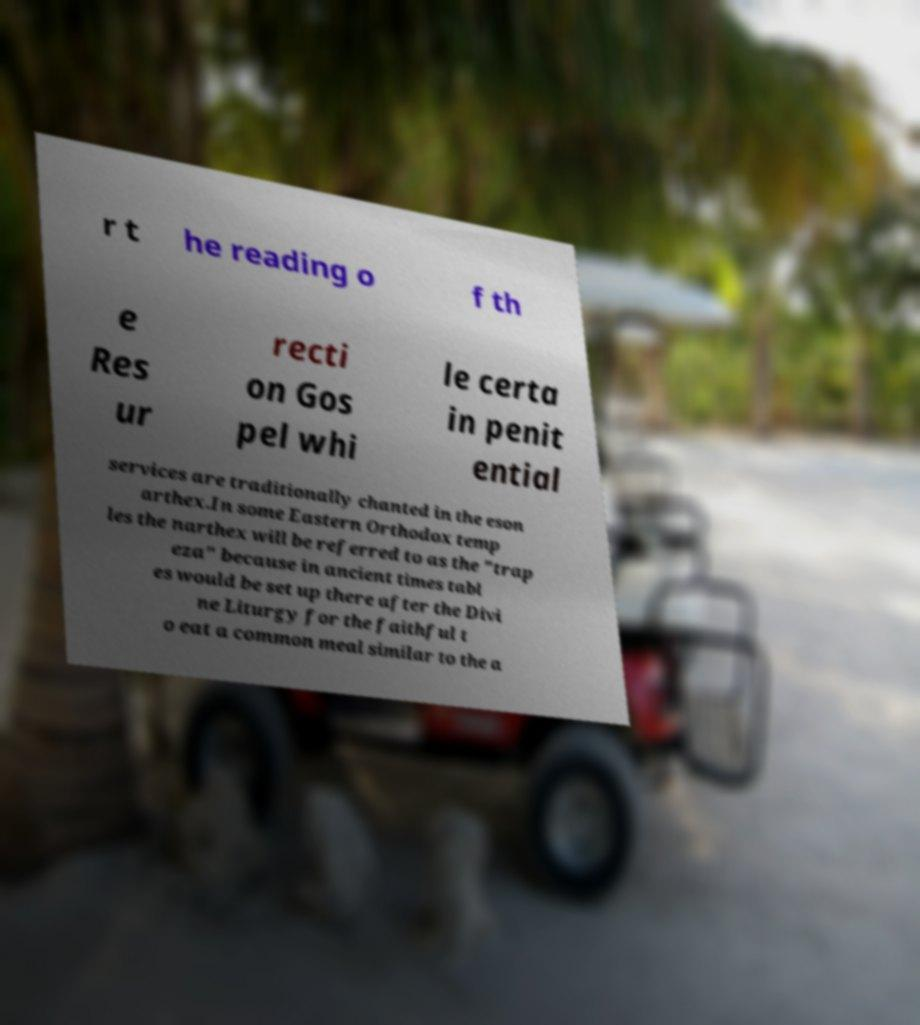Please read and relay the text visible in this image. What does it say? r t he reading o f th e Res ur recti on Gos pel whi le certa in penit ential services are traditionally chanted in the eson arthex.In some Eastern Orthodox temp les the narthex will be referred to as the "trap eza" because in ancient times tabl es would be set up there after the Divi ne Liturgy for the faithful t o eat a common meal similar to the a 